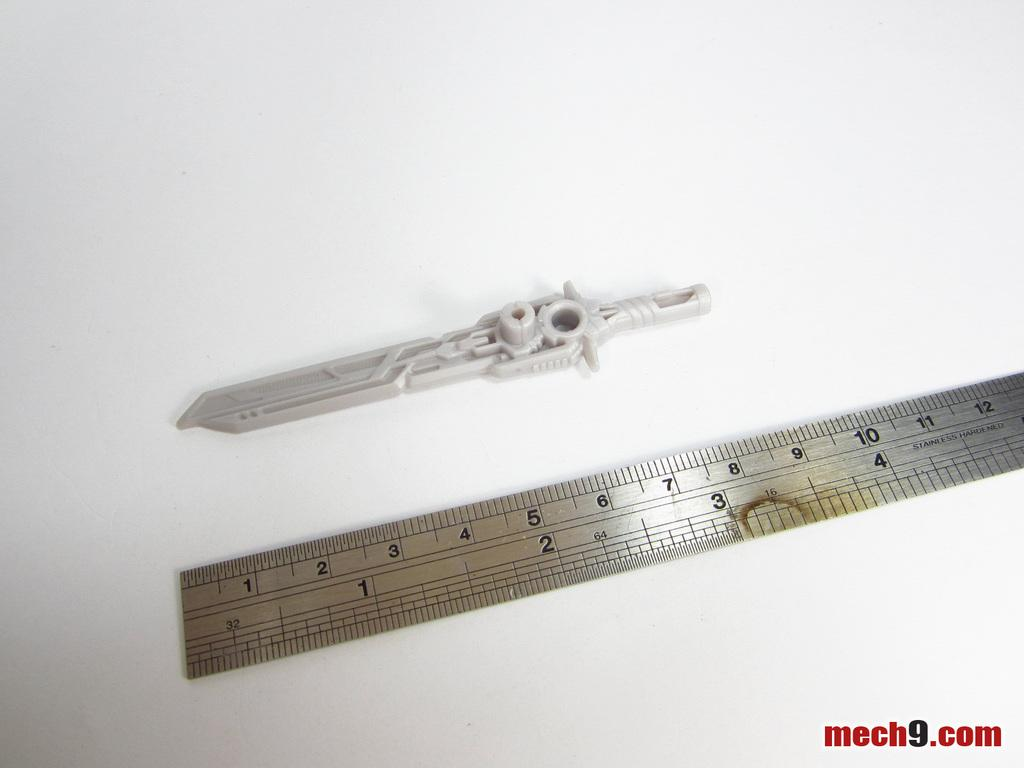<image>
Share a concise interpretation of the image provided. A ruler that says "stainless hardened" on it is lying next to a small plastic knife. 